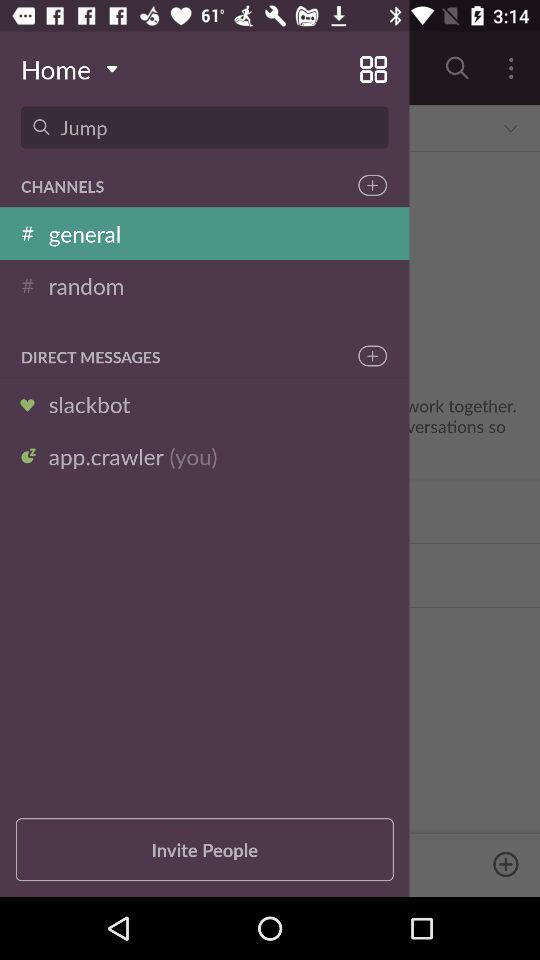What is the username? The usernames are "slackbot" and "app.crawler". 